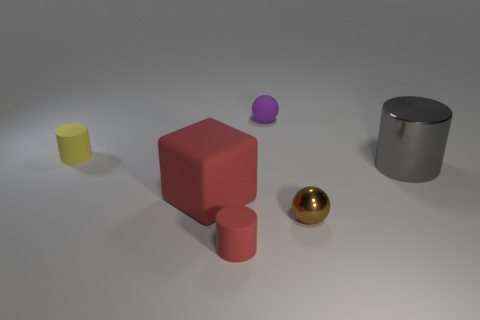Add 2 big brown rubber cylinders. How many objects exist? 8 Subtract all spheres. How many objects are left? 4 Subtract all balls. Subtract all large yellow cubes. How many objects are left? 4 Add 4 cubes. How many cubes are left? 5 Add 1 yellow matte cylinders. How many yellow matte cylinders exist? 2 Subtract 0 red spheres. How many objects are left? 6 